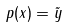<formula> <loc_0><loc_0><loc_500><loc_500>p ( x ) = \tilde { y }</formula> 